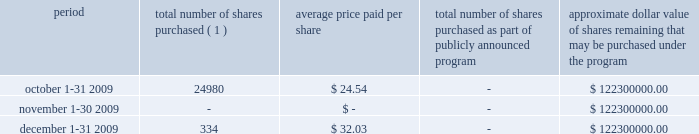We are required under the terms of our preferred stock to pay scheduled quarterly dividends , subject to legally available funds .
For so long as the preferred stock remains outstanding , ( 1 ) we will not declare , pay or set apart funds for the payment of any dividend or other distribution with respect to any junior stock or parity stock and ( 2 ) neither we , nor any of our subsidiaries , will , subject to certain exceptions , redeem , purchase or otherwise acquire for consideration junior stock or parity stock through a sinking fund or otherwise , in each case unless we have paid or set apart funds for the payment of all accumulated and unpaid dividends with respect to the shares of preferred stock and any parity stock for all preceding dividend periods .
Pursuant to this policy , we paid quarterly dividends of $ 0.265625 per share on our preferred stock on february 1 , 2009 , may 1 , 2009 , august 3 , 2009 and november 2 , 2009 and similar quarterly dividends during each quarter of 2008 .
The annual cash dividend declared and paid during the years ended december 31 , 2009 and 2008 were $ 10 million and $ 10 million , respectively .
On january 5 , 2010 , we declared a cash dividend of $ 0.265625 per share on our preferred stock amounting to $ 3 million and a cash dividend of $ 0.04 per share on our series a common stock amounting to $ 6 million .
Both cash dividends are for the period from november 2 , 2009 to january 31 , 2010 and were paid on february 1 , 2010 to holders of record as of january 15 , 2010 .
On february 1 , 2010 , we announced we would elect to redeem all of our outstanding preferred stock on february 22 , 2010 .
Holders of the preferred stock also have the right to convert their shares at any time prior to 5:00 p.m. , new york city time , on february 19 , 2010 , the business day immediately preceding the february 22 , 2010 redemption date .
Based on the number of outstanding shares as of december 31 , 2009 and considering the redemption of our preferred stock , cash dividends to be paid in 2010 are expected to result in annual dividend payments less than those paid in 2009 .
The amount available to us to pay cash dividends is restricted by our senior credit agreement .
Any decision to declare and pay dividends in the future will be made at the discretion of our board of directors and will depend on , among other things , our results of operations , cash requirements , financial condition , contractual restrictions and other factors that our board of directors may deem relevant .
Celanese purchases of its equity securities the table below sets forth information regarding repurchases of our series a common stock during the three months ended december 31 , 2009 : period total number of shares purchased ( 1 ) average price paid per share total number of shares purchased as part of publicly announced program approximate dollar value of shares remaining that may be purchased under the program .
( 1 ) relates to shares employees have elected to have withheld to cover their statutory minimum withholding requirements for personal income taxes related to the vesting of restricted stock units .
No shares were purchased during the three months ended december 31 , 2009 under our previously announced stock repurchase plan .
%%transmsg*** transmitting job : d70731 pcn : 033000000 ***%%pcmsg|33 |00012|yes|no|02/10/2010 05:41|0|0|page is valid , no graphics -- color : n| .
What is the value of the shares purchased between december 1-31 2009? 
Computations: (334 * 32.03)
Answer: 10698.02. We are required under the terms of our preferred stock to pay scheduled quarterly dividends , subject to legally available funds .
For so long as the preferred stock remains outstanding , ( 1 ) we will not declare , pay or set apart funds for the payment of any dividend or other distribution with respect to any junior stock or parity stock and ( 2 ) neither we , nor any of our subsidiaries , will , subject to certain exceptions , redeem , purchase or otherwise acquire for consideration junior stock or parity stock through a sinking fund or otherwise , in each case unless we have paid or set apart funds for the payment of all accumulated and unpaid dividends with respect to the shares of preferred stock and any parity stock for all preceding dividend periods .
Pursuant to this policy , we paid quarterly dividends of $ 0.265625 per share on our preferred stock on february 1 , 2009 , may 1 , 2009 , august 3 , 2009 and november 2 , 2009 and similar quarterly dividends during each quarter of 2008 .
The annual cash dividend declared and paid during the years ended december 31 , 2009 and 2008 were $ 10 million and $ 10 million , respectively .
On january 5 , 2010 , we declared a cash dividend of $ 0.265625 per share on our preferred stock amounting to $ 3 million and a cash dividend of $ 0.04 per share on our series a common stock amounting to $ 6 million .
Both cash dividends are for the period from november 2 , 2009 to january 31 , 2010 and were paid on february 1 , 2010 to holders of record as of january 15 , 2010 .
On february 1 , 2010 , we announced we would elect to redeem all of our outstanding preferred stock on february 22 , 2010 .
Holders of the preferred stock also have the right to convert their shares at any time prior to 5:00 p.m. , new york city time , on february 19 , 2010 , the business day immediately preceding the february 22 , 2010 redemption date .
Based on the number of outstanding shares as of december 31 , 2009 and considering the redemption of our preferred stock , cash dividends to be paid in 2010 are expected to result in annual dividend payments less than those paid in 2009 .
The amount available to us to pay cash dividends is restricted by our senior credit agreement .
Any decision to declare and pay dividends in the future will be made at the discretion of our board of directors and will depend on , among other things , our results of operations , cash requirements , financial condition , contractual restrictions and other factors that our board of directors may deem relevant .
Celanese purchases of its equity securities the table below sets forth information regarding repurchases of our series a common stock during the three months ended december 31 , 2009 : period total number of shares purchased ( 1 ) average price paid per share total number of shares purchased as part of publicly announced program approximate dollar value of shares remaining that may be purchased under the program .
( 1 ) relates to shares employees have elected to have withheld to cover their statutory minimum withholding requirements for personal income taxes related to the vesting of restricted stock units .
No shares were purchased during the three months ended december 31 , 2009 under our previously announced stock repurchase plan .
%%transmsg*** transmitting job : d70731 pcn : 033000000 ***%%pcmsg|33 |00012|yes|no|02/10/2010 05:41|0|0|page is valid , no graphics -- color : n| .
What is the value of the shares purchased between october 1-31 2009? 
Computations: (24980 * 24.54)
Answer: 613009.2. 